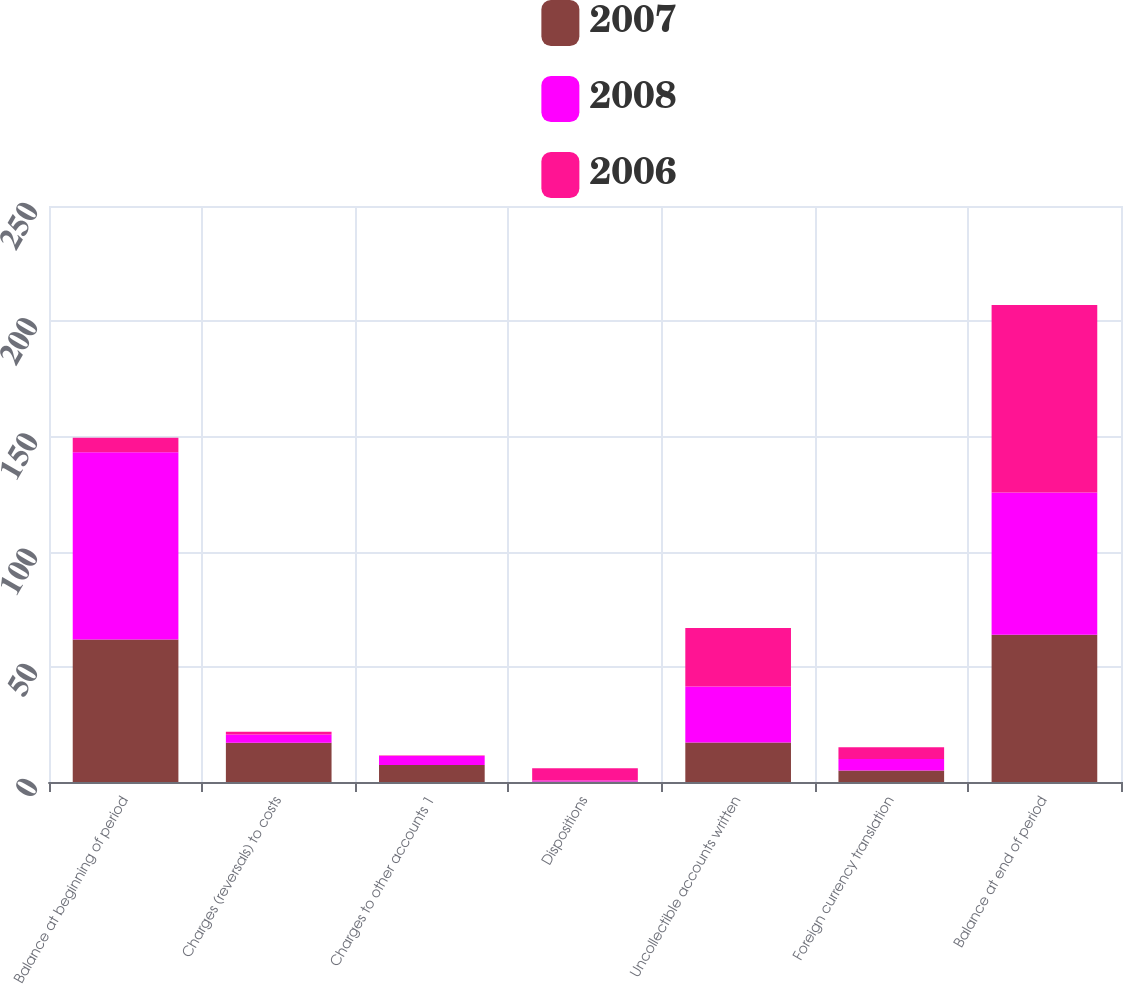Convert chart. <chart><loc_0><loc_0><loc_500><loc_500><stacked_bar_chart><ecel><fcel>Balance at beginning of period<fcel>Charges (reversals) to costs<fcel>Charges to other accounts 1<fcel>Dispositions<fcel>Uncollectible accounts written<fcel>Foreign currency translation<fcel>Balance at end of period<nl><fcel>2007<fcel>61.8<fcel>17<fcel>7.4<fcel>0.2<fcel>17.1<fcel>5<fcel>63.9<nl><fcel>2008<fcel>81.3<fcel>3.6<fcel>3.9<fcel>0.5<fcel>24.3<fcel>5<fcel>61.8<nl><fcel>2006<fcel>6.35<fcel>1.2<fcel>0.2<fcel>5.3<fcel>25.4<fcel>5.1<fcel>81.3<nl></chart> 